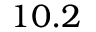<formula> <loc_0><loc_0><loc_500><loc_500>1 0 . 2</formula> 